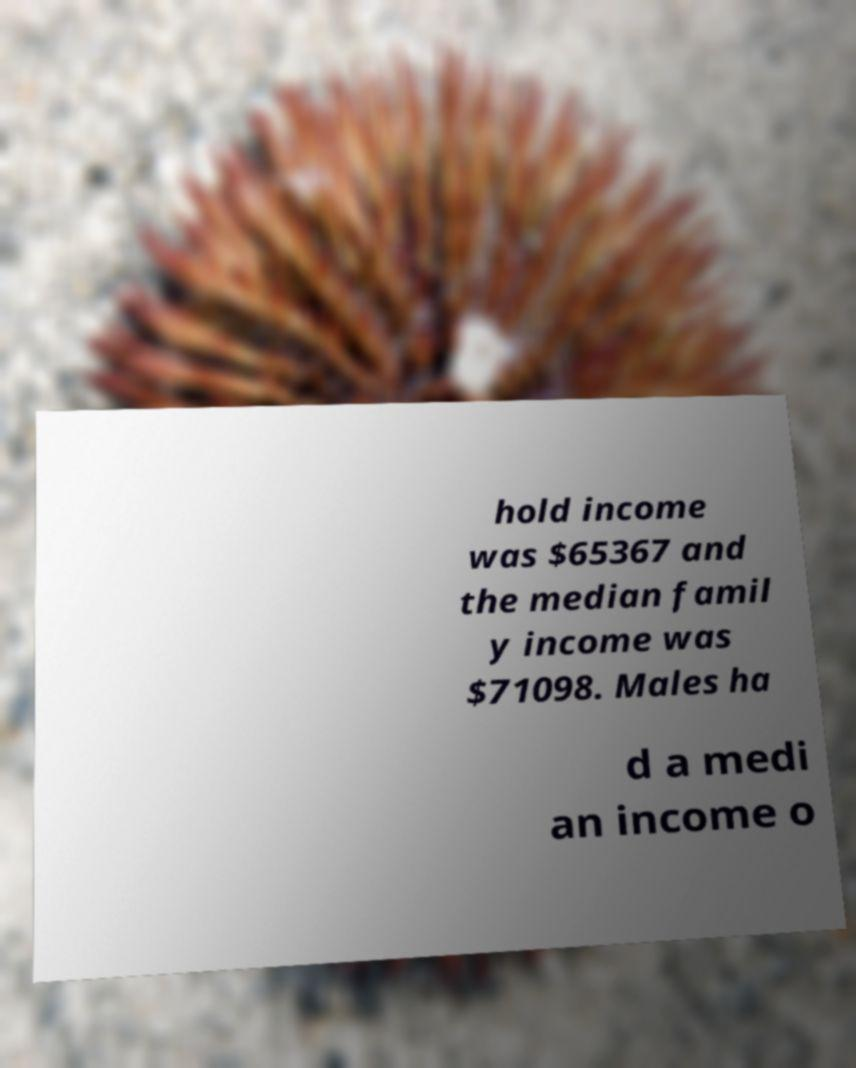Please read and relay the text visible in this image. What does it say? hold income was $65367 and the median famil y income was $71098. Males ha d a medi an income o 